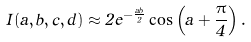Convert formula to latex. <formula><loc_0><loc_0><loc_500><loc_500>I ( a , b , c , d ) \approx 2 e ^ { - \frac { a b } { 2 } } \cos \left ( a + \frac { \pi } { 4 } \right ) .</formula> 